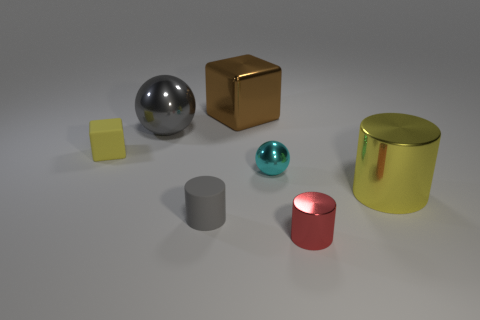Do the metal cylinder right of the red cylinder and the tiny gray thing have the same size?
Provide a short and direct response. No. There is a tiny thing on the left side of the small gray thing; what is its material?
Provide a short and direct response. Rubber. Is there any other thing that has the same shape as the big yellow object?
Your answer should be compact. Yes. What number of metal things are either cyan things or tiny blocks?
Make the answer very short. 1. Are there fewer gray balls right of the tiny shiny cylinder than rubber balls?
Offer a very short reply. No. What is the shape of the gray object that is in front of the metal sphere that is in front of the tiny rubber object behind the gray cylinder?
Your answer should be compact. Cylinder. Does the small block have the same color as the large block?
Your answer should be very brief. No. Is the number of green cubes greater than the number of shiny things?
Make the answer very short. No. What number of other things are made of the same material as the tiny yellow cube?
Your answer should be compact. 1. What number of things are either large yellow metal cylinders or metal objects that are on the right side of the big gray thing?
Your response must be concise. 4. 